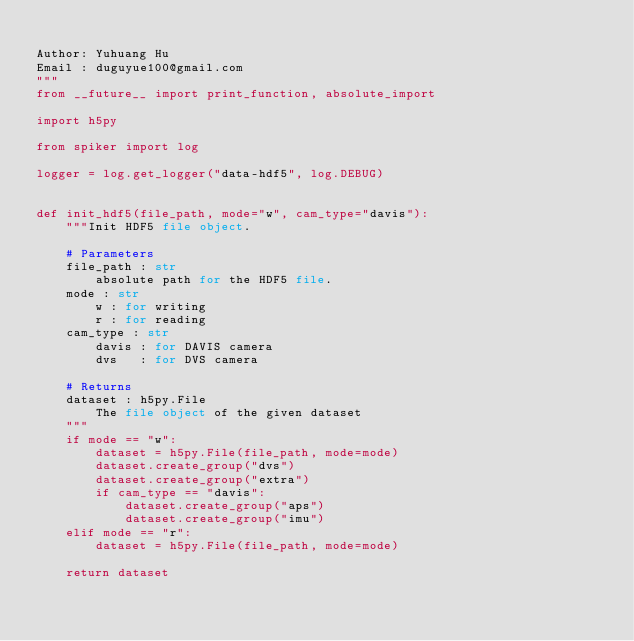<code> <loc_0><loc_0><loc_500><loc_500><_Python_>
Author: Yuhuang Hu
Email : duguyue100@gmail.com
"""
from __future__ import print_function, absolute_import

import h5py

from spiker import log

logger = log.get_logger("data-hdf5", log.DEBUG)


def init_hdf5(file_path, mode="w", cam_type="davis"):
    """Init HDF5 file object.

    # Parameters
    file_path : str
        absolute path for the HDF5 file.
    mode : str
        w : for writing
        r : for reading
    cam_type : str
        davis : for DAVIS camera
        dvs   : for DVS camera

    # Returns
    dataset : h5py.File
        The file object of the given dataset
    """
    if mode == "w":
        dataset = h5py.File(file_path, mode=mode)
        dataset.create_group("dvs")
        dataset.create_group("extra")
        if cam_type == "davis":
            dataset.create_group("aps")
            dataset.create_group("imu")
    elif mode == "r":
        dataset = h5py.File(file_path, mode=mode)

    return dataset
</code> 